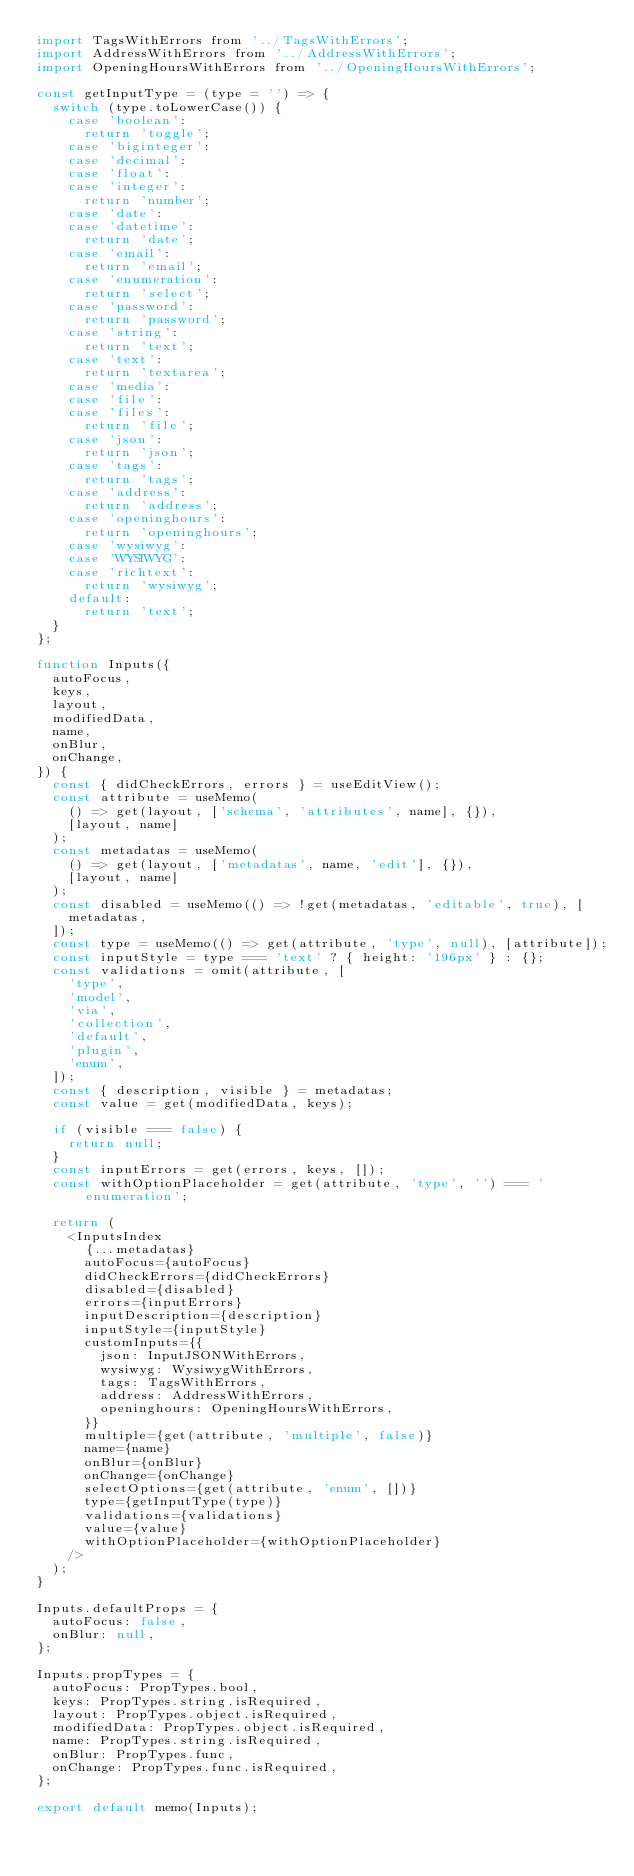<code> <loc_0><loc_0><loc_500><loc_500><_JavaScript_>import TagsWithErrors from '../TagsWithErrors';
import AddressWithErrors from '../AddressWithErrors';
import OpeningHoursWithErrors from '../OpeningHoursWithErrors';

const getInputType = (type = '') => {
  switch (type.toLowerCase()) {
    case 'boolean':
      return 'toggle';
    case 'biginteger':
    case 'decimal':
    case 'float':
    case 'integer':
      return 'number';
    case 'date':
    case 'datetime':
      return 'date';
    case 'email':
      return 'email';
    case 'enumeration':
      return 'select';
    case 'password':
      return 'password';
    case 'string':
      return 'text';
    case 'text':
      return 'textarea';
    case 'media':
    case 'file':
    case 'files':
      return 'file';
    case 'json':
      return 'json';
    case 'tags':
      return 'tags';
    case 'address':
      return 'address';
    case 'openinghours':
      return 'openinghours';
    case 'wysiwyg':
    case 'WYSIWYG':
    case 'richtext':
      return 'wysiwyg';
    default:
      return 'text';
  }
};

function Inputs({
  autoFocus,
  keys,
  layout,
  modifiedData,
  name,
  onBlur,
  onChange,
}) {
  const { didCheckErrors, errors } = useEditView();
  const attribute = useMemo(
    () => get(layout, ['schema', 'attributes', name], {}),
    [layout, name]
  );
  const metadatas = useMemo(
    () => get(layout, ['metadatas', name, 'edit'], {}),
    [layout, name]
  );
  const disabled = useMemo(() => !get(metadatas, 'editable', true), [
    metadatas,
  ]);
  const type = useMemo(() => get(attribute, 'type', null), [attribute]);
  const inputStyle = type === 'text' ? { height: '196px' } : {};
  const validations = omit(attribute, [
    'type',
    'model',
    'via',
    'collection',
    'default',
    'plugin',
    'enum',
  ]);
  const { description, visible } = metadatas;
  const value = get(modifiedData, keys);

  if (visible === false) {
    return null;
  }
  const inputErrors = get(errors, keys, []);
  const withOptionPlaceholder = get(attribute, 'type', '') === 'enumeration';

  return (
    <InputsIndex
      {...metadatas}
      autoFocus={autoFocus}
      didCheckErrors={didCheckErrors}
      disabled={disabled}
      errors={inputErrors}
      inputDescription={description}
      inputStyle={inputStyle}
      customInputs={{
        json: InputJSONWithErrors,
        wysiwyg: WysiwygWithErrors,
        tags: TagsWithErrors,
        address: AddressWithErrors,
        openinghours: OpeningHoursWithErrors,
      }}
      multiple={get(attribute, 'multiple', false)}
      name={name}
      onBlur={onBlur}
      onChange={onChange}
      selectOptions={get(attribute, 'enum', [])}
      type={getInputType(type)}
      validations={validations}
      value={value}
      withOptionPlaceholder={withOptionPlaceholder}
    />
  );
}

Inputs.defaultProps = {
  autoFocus: false,
  onBlur: null,
};

Inputs.propTypes = {
  autoFocus: PropTypes.bool,
  keys: PropTypes.string.isRequired,
  layout: PropTypes.object.isRequired,
  modifiedData: PropTypes.object.isRequired,
  name: PropTypes.string.isRequired,
  onBlur: PropTypes.func,
  onChange: PropTypes.func.isRequired,
};

export default memo(Inputs);
</code> 